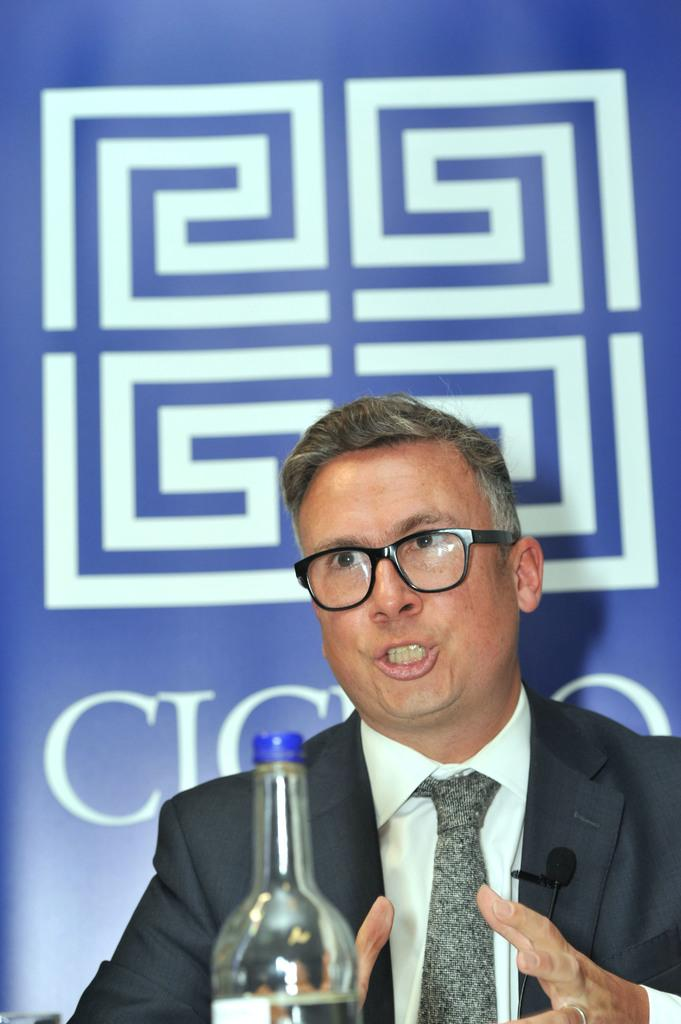What is the man in the image doing? The man is sitting and talking in the center of the image. Can you describe the man's appearance? The man is wearing glasses. What object is in front of the man? There is a bottle before the man. What can be seen in the background of the image? There is a board in the background of the image. How many pizzas are being delivered to the man in the image? There are no pizzas present in the image, nor is there any indication of a delivery. Can you describe the trail the man is following in the image? There is no trail visible in the image; it features a man sitting and talking with a bottle and a board in the background. 